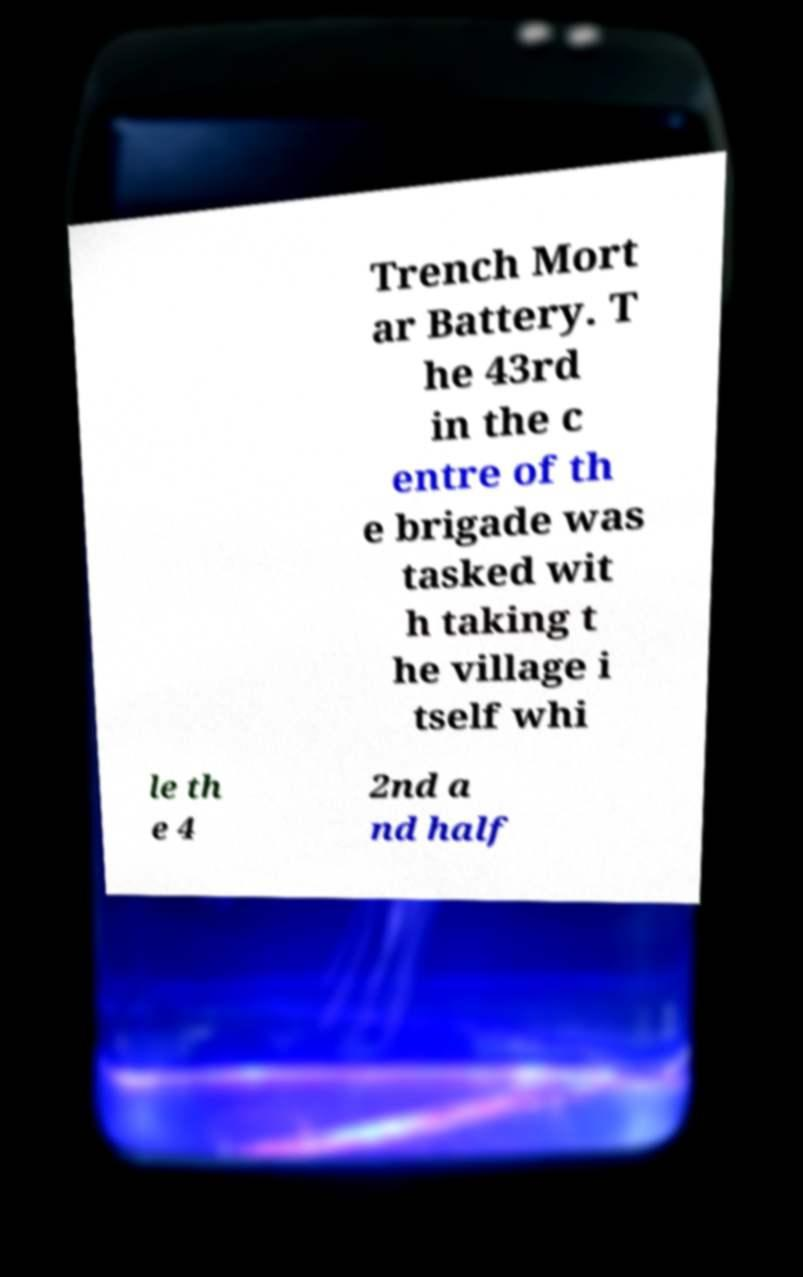Can you accurately transcribe the text from the provided image for me? Trench Mort ar Battery. T he 43rd in the c entre of th e brigade was tasked wit h taking t he village i tself whi le th e 4 2nd a nd half 